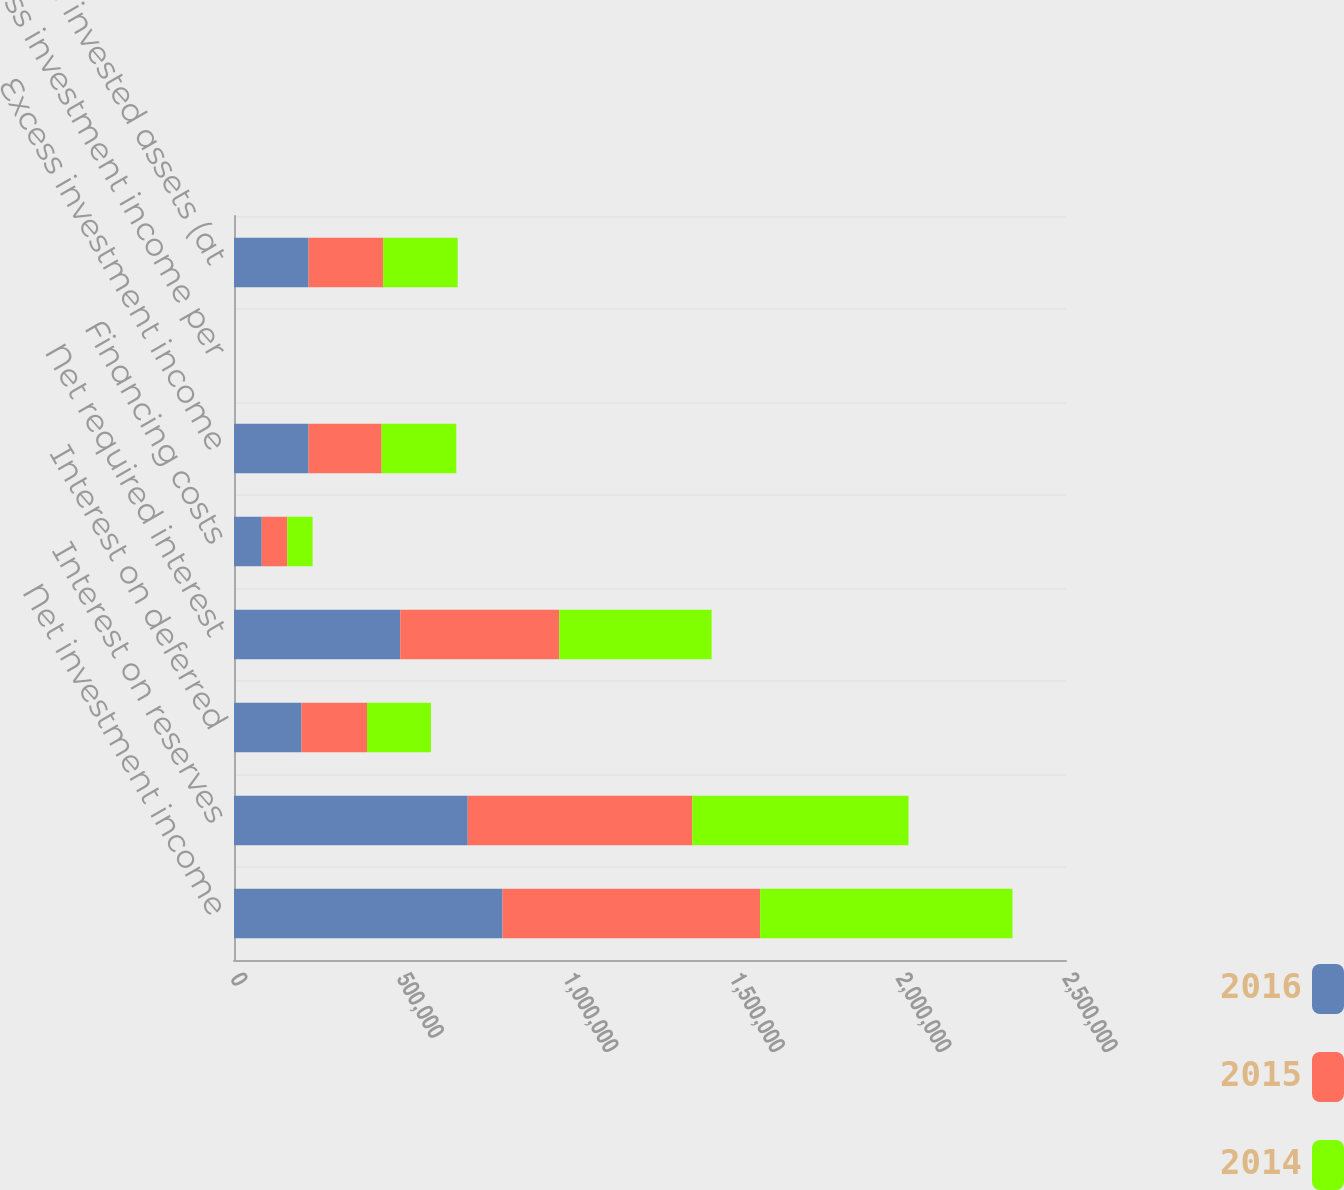Convert chart. <chart><loc_0><loc_0><loc_500><loc_500><stacked_bar_chart><ecel><fcel>Net investment income<fcel>Interest on reserves<fcel>Interest on deferred<fcel>Net required interest<fcel>Financing costs<fcel>Excess investment income<fcel>Excess investment income per<fcel>Mean invested assets (at<nl><fcel>2016<fcel>806903<fcel>702340<fcel>202813<fcel>499527<fcel>83345<fcel>224031<fcel>1.83<fcel>224031<nl><fcel>2015<fcel>773951<fcel>674650<fcel>196845<fcel>477805<fcel>76642<fcel>219504<fcel>1.73<fcel>224031<nl><fcel>2014<fcel>758286<fcel>649848<fcel>192052<fcel>457796<fcel>76126<fcel>224364<fcel>1.69<fcel>224031<nl></chart> 